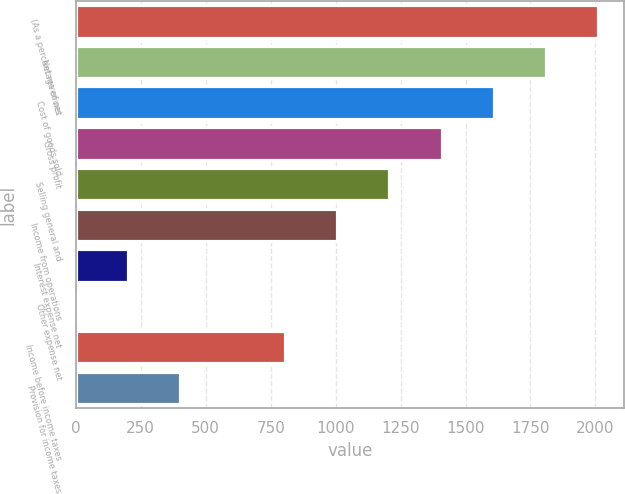Convert chart. <chart><loc_0><loc_0><loc_500><loc_500><bar_chart><fcel>(As a percentage of net<fcel>Net revenues<fcel>Cost of goods sold<fcel>Gross profit<fcel>Selling general and<fcel>Income from operations<fcel>Interest expense net<fcel>Other expense net<fcel>Income before income taxes<fcel>Provision for income taxes<nl><fcel>2011<fcel>1809.91<fcel>1608.82<fcel>1407.73<fcel>1206.64<fcel>1005.55<fcel>201.19<fcel>0.1<fcel>804.46<fcel>402.28<nl></chart> 